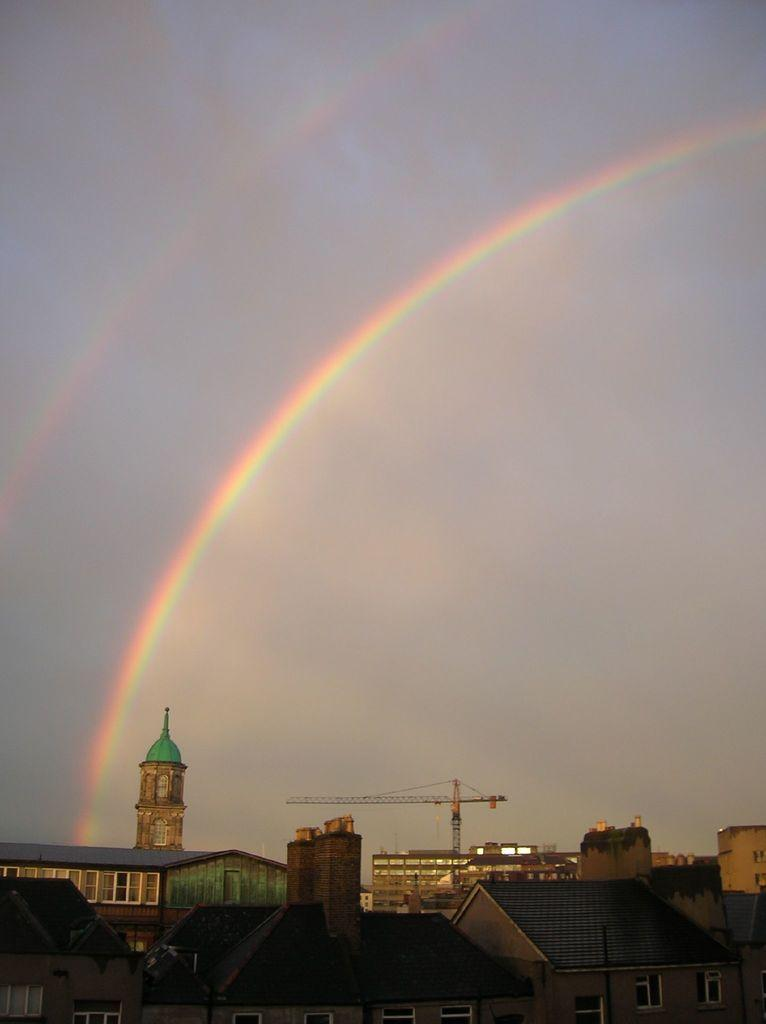What type of structures are visible in the image? There are houses in the image. What can be seen in the background of the image? There is a crane in the background of the image. What natural phenomenon is visible in the sky at the top of the image? There is a rainbow in the sky at the top of the image. What type of war is being fought in the image? There is no war present in the image; it features houses, a crane, and a rainbow. How are the houses being sorted in the image? The houses are not being sorted in the image; they are simply visible as structures. 